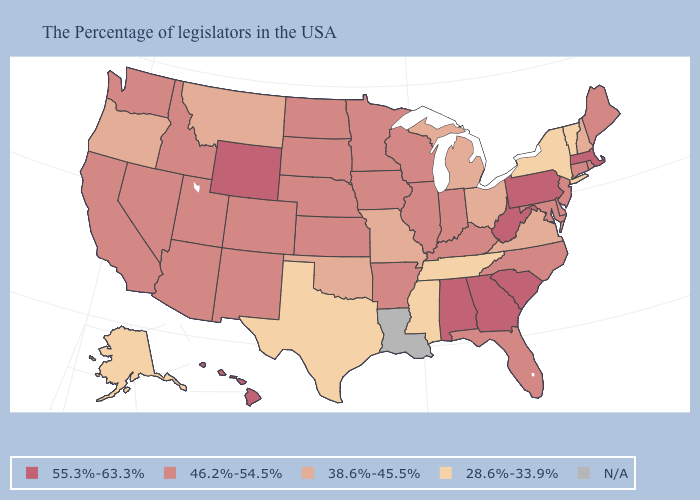What is the value of Indiana?
Concise answer only. 46.2%-54.5%. What is the value of West Virginia?
Be succinct. 55.3%-63.3%. Does Vermont have the lowest value in the USA?
Write a very short answer. Yes. What is the value of Wisconsin?
Be succinct. 46.2%-54.5%. Among the states that border Nevada , does Oregon have the highest value?
Give a very brief answer. No. Which states have the highest value in the USA?
Answer briefly. Massachusetts, Pennsylvania, South Carolina, West Virginia, Georgia, Alabama, Wyoming, Hawaii. How many symbols are there in the legend?
Answer briefly. 5. Does South Carolina have the highest value in the USA?
Answer briefly. Yes. Is the legend a continuous bar?
Give a very brief answer. No. What is the value of Nevada?
Quick response, please. 46.2%-54.5%. What is the lowest value in the West?
Be succinct. 28.6%-33.9%. Name the states that have a value in the range 38.6%-45.5%?
Keep it brief. New Hampshire, Virginia, Ohio, Michigan, Missouri, Oklahoma, Montana, Oregon. Name the states that have a value in the range 46.2%-54.5%?
Write a very short answer. Maine, Rhode Island, Connecticut, New Jersey, Delaware, Maryland, North Carolina, Florida, Kentucky, Indiana, Wisconsin, Illinois, Arkansas, Minnesota, Iowa, Kansas, Nebraska, South Dakota, North Dakota, Colorado, New Mexico, Utah, Arizona, Idaho, Nevada, California, Washington. Name the states that have a value in the range 55.3%-63.3%?
Answer briefly. Massachusetts, Pennsylvania, South Carolina, West Virginia, Georgia, Alabama, Wyoming, Hawaii. 